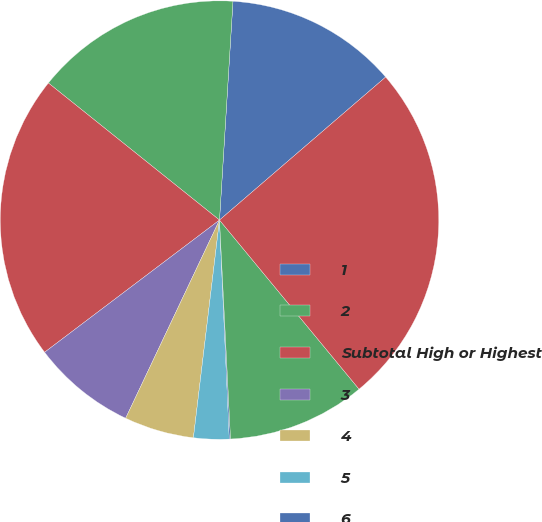<chart> <loc_0><loc_0><loc_500><loc_500><pie_chart><fcel>1<fcel>2<fcel>Subtotal High or Highest<fcel>3<fcel>4<fcel>5<fcel>6<fcel>Subtotal Other Securities(2)<fcel>Total Private Fixed Maturities<nl><fcel>12.71%<fcel>15.23%<fcel>21.05%<fcel>7.66%<fcel>5.14%<fcel>2.61%<fcel>0.09%<fcel>10.18%<fcel>25.33%<nl></chart> 